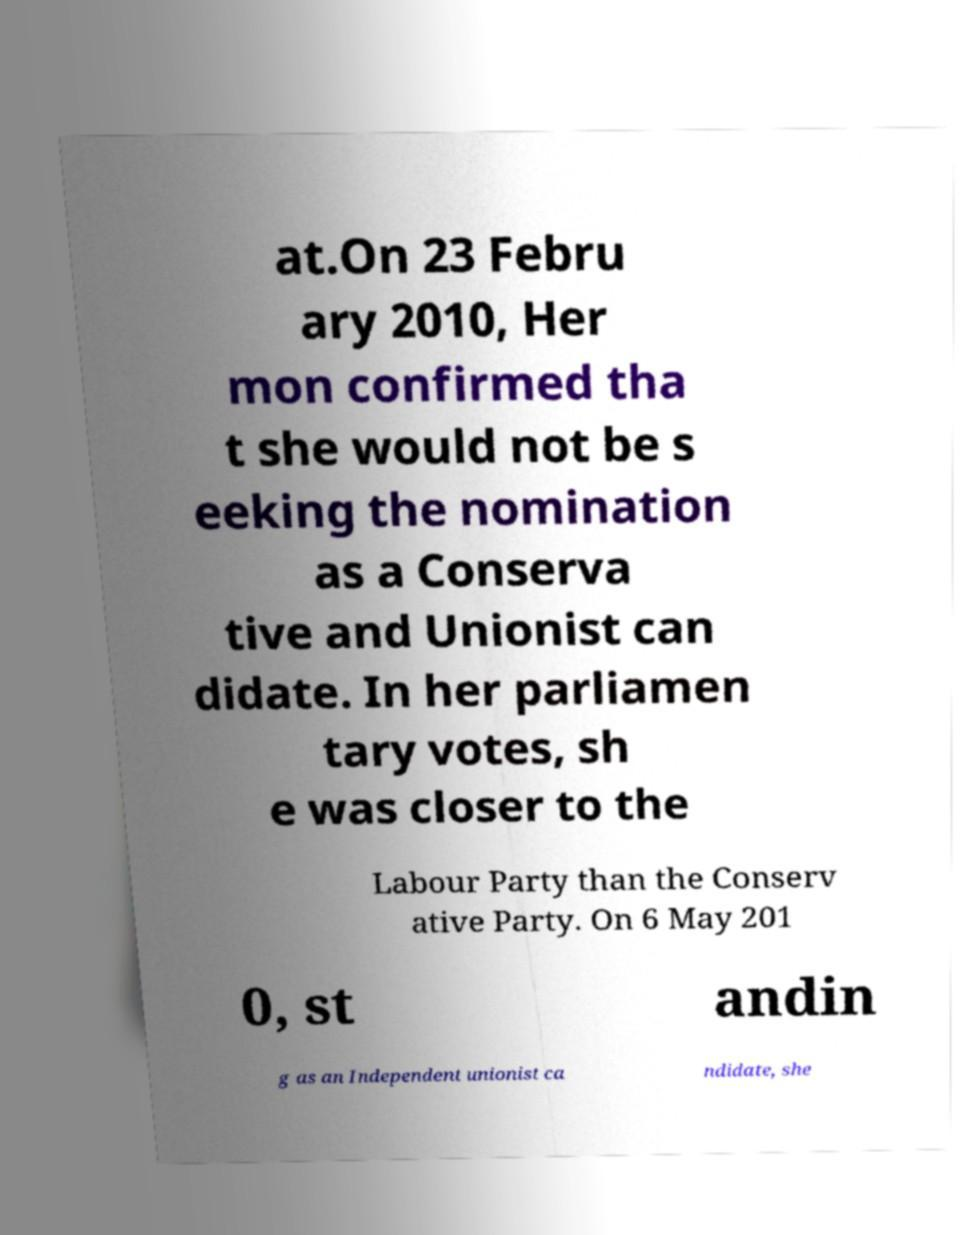For documentation purposes, I need the text within this image transcribed. Could you provide that? at.On 23 Febru ary 2010, Her mon confirmed tha t she would not be s eeking the nomination as a Conserva tive and Unionist can didate. In her parliamen tary votes, sh e was closer to the Labour Party than the Conserv ative Party. On 6 May 201 0, st andin g as an Independent unionist ca ndidate, she 